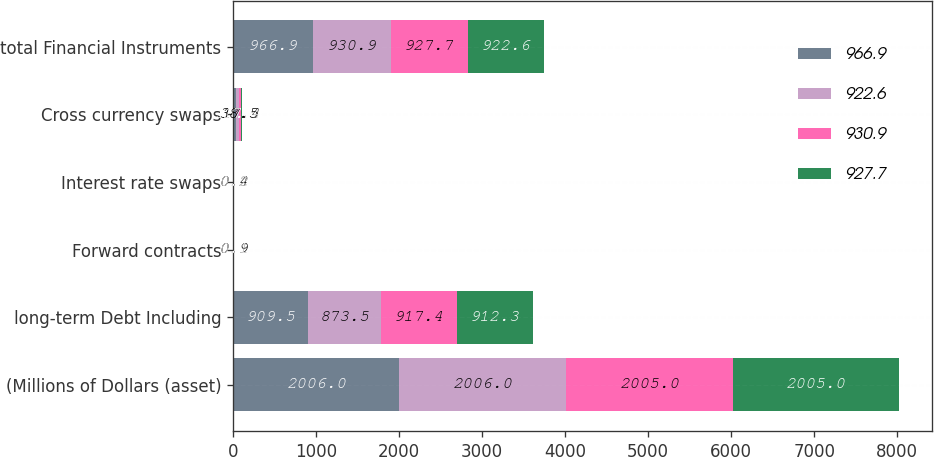<chart> <loc_0><loc_0><loc_500><loc_500><stacked_bar_chart><ecel><fcel>(Millions of Dollars (asset)<fcel>long-term Debt Including<fcel>Forward contracts<fcel>Interest rate swaps<fcel>Cross currency swaps<fcel>total Financial Instruments<nl><fcel>966.9<fcel>2006<fcel>909.5<fcel>0.9<fcel>0.4<fcel>38.5<fcel>966.9<nl><fcel>922.6<fcel>2006<fcel>873.5<fcel>0.9<fcel>0.4<fcel>38.5<fcel>930.9<nl><fcel>930.9<fcel>2005<fcel>917.4<fcel>0.1<fcel>0.2<fcel>17.4<fcel>927.7<nl><fcel>927.7<fcel>2005<fcel>912.3<fcel>0.1<fcel>0.2<fcel>17.4<fcel>922.6<nl></chart> 